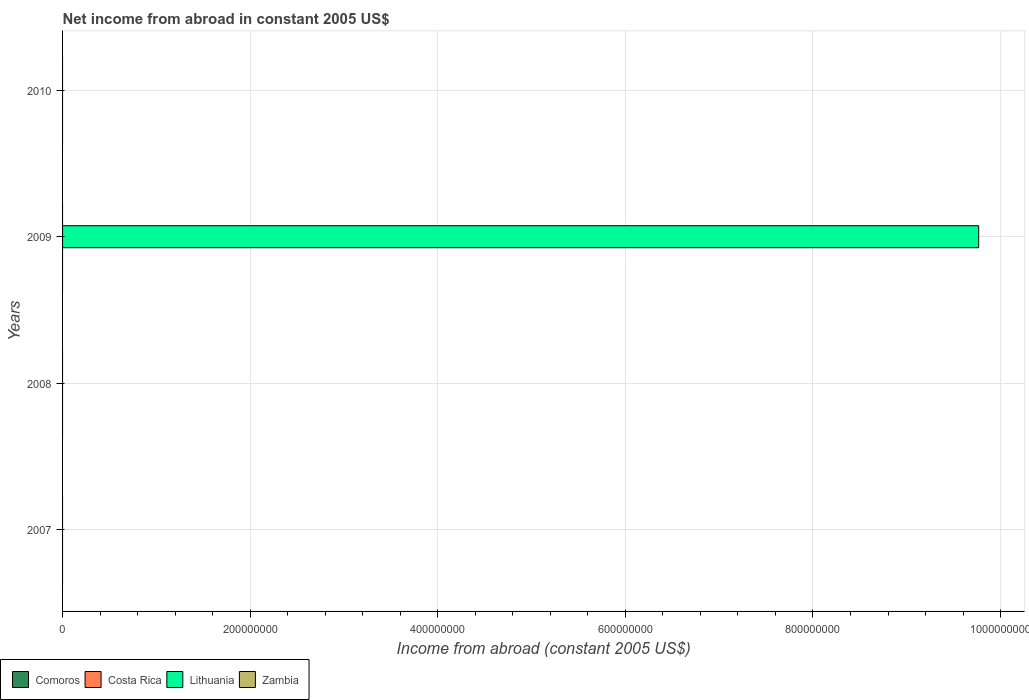How many different coloured bars are there?
Provide a short and direct response. 1. Are the number of bars per tick equal to the number of legend labels?
Provide a succinct answer. No. Are the number of bars on each tick of the Y-axis equal?
Offer a terse response. No. How many bars are there on the 3rd tick from the bottom?
Make the answer very short. 1. In how many cases, is the number of bars for a given year not equal to the number of legend labels?
Keep it short and to the point. 4. What is the net income from abroad in Costa Rica in 2009?
Provide a short and direct response. 0. Across all years, what is the maximum net income from abroad in Lithuania?
Your response must be concise. 9.77e+08. What is the total net income from abroad in Costa Rica in the graph?
Make the answer very short. 0. What is the difference between the net income from abroad in Costa Rica in 2010 and the net income from abroad in Lithuania in 2009?
Make the answer very short. -9.77e+08. What is the difference between the highest and the lowest net income from abroad in Lithuania?
Your answer should be very brief. 9.77e+08. In how many years, is the net income from abroad in Costa Rica greater than the average net income from abroad in Costa Rica taken over all years?
Your answer should be very brief. 0. How many bars are there?
Give a very brief answer. 1. How many years are there in the graph?
Give a very brief answer. 4. Are the values on the major ticks of X-axis written in scientific E-notation?
Offer a terse response. No. Does the graph contain any zero values?
Make the answer very short. Yes. Does the graph contain grids?
Your answer should be compact. Yes. How many legend labels are there?
Provide a succinct answer. 4. What is the title of the graph?
Provide a succinct answer. Net income from abroad in constant 2005 US$. Does "Georgia" appear as one of the legend labels in the graph?
Provide a succinct answer. No. What is the label or title of the X-axis?
Keep it short and to the point. Income from abroad (constant 2005 US$). What is the label or title of the Y-axis?
Your response must be concise. Years. What is the Income from abroad (constant 2005 US$) in Lithuania in 2007?
Your response must be concise. 0. What is the Income from abroad (constant 2005 US$) of Lithuania in 2008?
Your response must be concise. 0. What is the Income from abroad (constant 2005 US$) of Zambia in 2008?
Your response must be concise. 0. What is the Income from abroad (constant 2005 US$) in Lithuania in 2009?
Your response must be concise. 9.77e+08. What is the Income from abroad (constant 2005 US$) of Zambia in 2009?
Your response must be concise. 0. What is the Income from abroad (constant 2005 US$) in Lithuania in 2010?
Keep it short and to the point. 0. Across all years, what is the maximum Income from abroad (constant 2005 US$) of Lithuania?
Your response must be concise. 9.77e+08. Across all years, what is the minimum Income from abroad (constant 2005 US$) of Lithuania?
Your answer should be very brief. 0. What is the total Income from abroad (constant 2005 US$) of Costa Rica in the graph?
Make the answer very short. 0. What is the total Income from abroad (constant 2005 US$) in Lithuania in the graph?
Your answer should be very brief. 9.77e+08. What is the average Income from abroad (constant 2005 US$) in Lithuania per year?
Provide a short and direct response. 2.44e+08. What is the average Income from abroad (constant 2005 US$) of Zambia per year?
Provide a short and direct response. 0. What is the difference between the highest and the lowest Income from abroad (constant 2005 US$) of Lithuania?
Provide a short and direct response. 9.77e+08. 